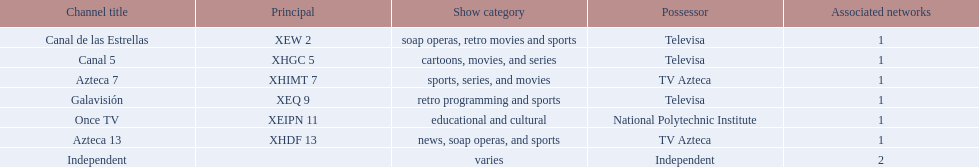Azteca 7 and azteca 13 are both owned by whom? TV Azteca. 